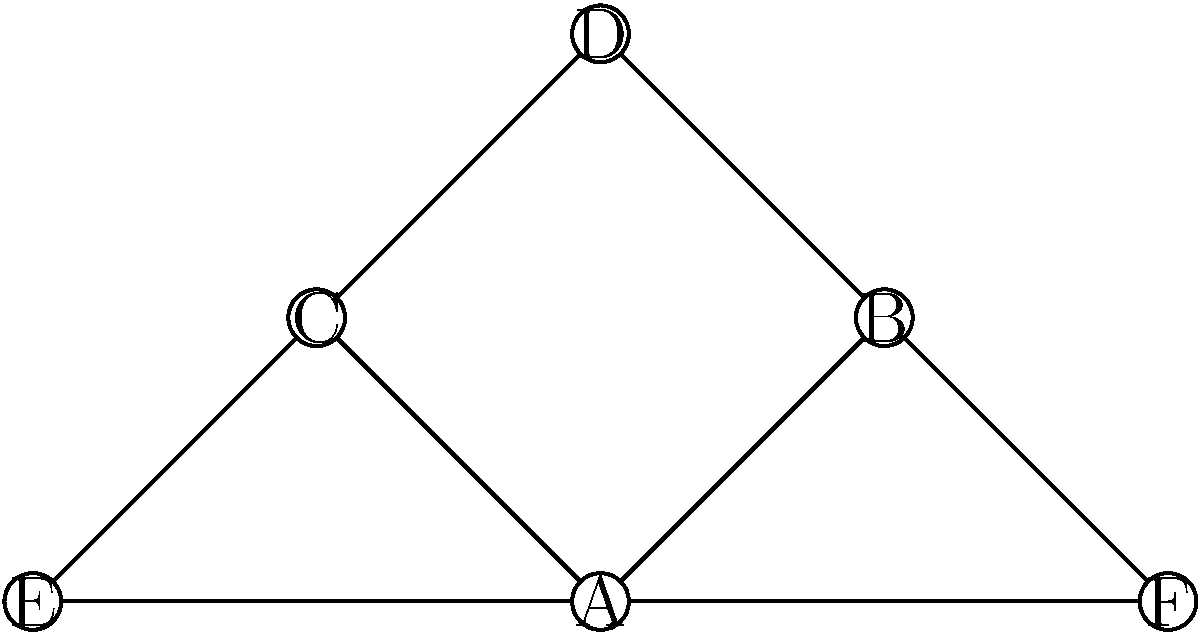In the network diagram above, each node represents a subplot in a novel, and the connections between nodes indicate narrative links between subplots. As a detail-oriented book editor, analyze the structure and identify which subplot (represented by a letter) serves as the primary connecting point for the majority of other subplots. Explain how this central subplot might impact the overall narrative cohesion and character development in the story. To determine the primary connecting subplot, we need to follow these steps:

1. Count the connections for each node:
   A: 4 connections (B, C, E, F)
   B: 3 connections (A, D, F)
   C: 3 connections (A, D, E)
   D: 2 connections (B, C)
   E: 2 connections (A, C)
   F: 2 connections (A, B)

2. Identify the node with the most connections:
   Node A has the most connections with 4.

3. Analyze the impact on narrative cohesion:
   - Subplot A serves as a central hub, connecting to four other subplots (B, C, E, F).
   - This structure suggests that subplot A is crucial to the overall story, as it intertwines with the majority of other narrative threads.
   - The centrality of subplot A can help maintain narrative cohesion by providing a common thread that ties various story elements together.

4. Consider the effect on character development:
   - Characters involved in subplot A are likely to have interactions with characters from multiple other subplots, allowing for more complex relationship dynamics.
   - This interconnectedness can lead to richer character arcs as characters navigate the various plot threads connected to subplot A.
   - The central nature of subplot A may also indicate that the characters involved in this subplot undergo the most significant development throughout the story.

5. Evaluate the storytelling implications:
   - The network structure emphasizes the importance of subplot A in driving the overall narrative.
   - Authors and editors should ensure that subplot A is well-developed and engaging, as it bears the weight of connecting the other story elements.
   - The structure also allows for diverse storytelling techniques, such as parallel narratives or multi-perspective approaches, all anchored by the central subplot A.
Answer: Subplot A 